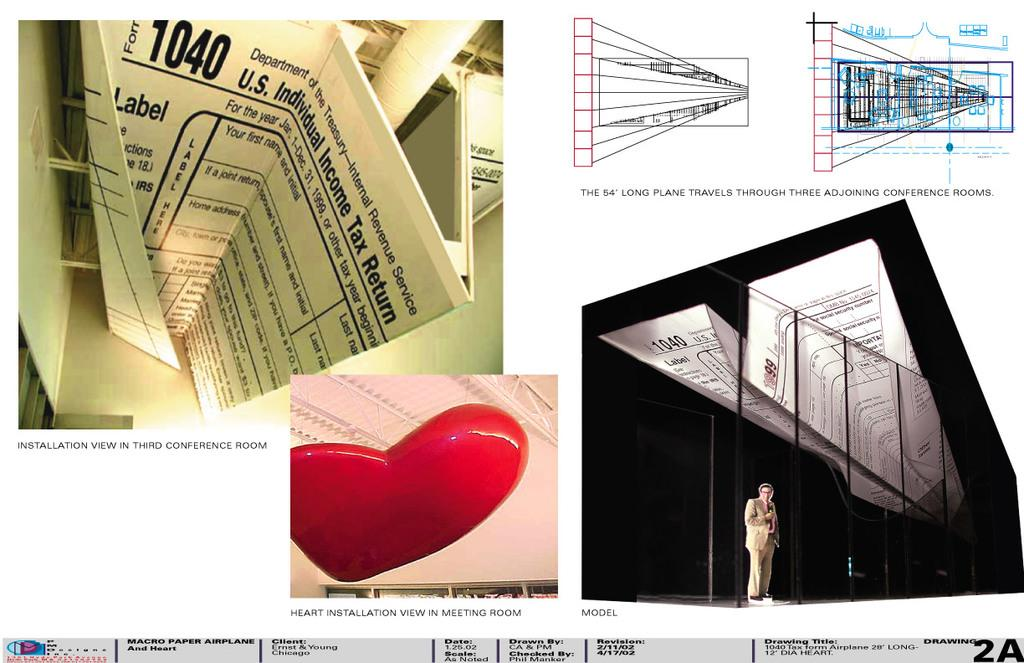<image>
Provide a brief description of the given image. Paper airplanes made of 1040 tax forms with a heart on the bottom. 